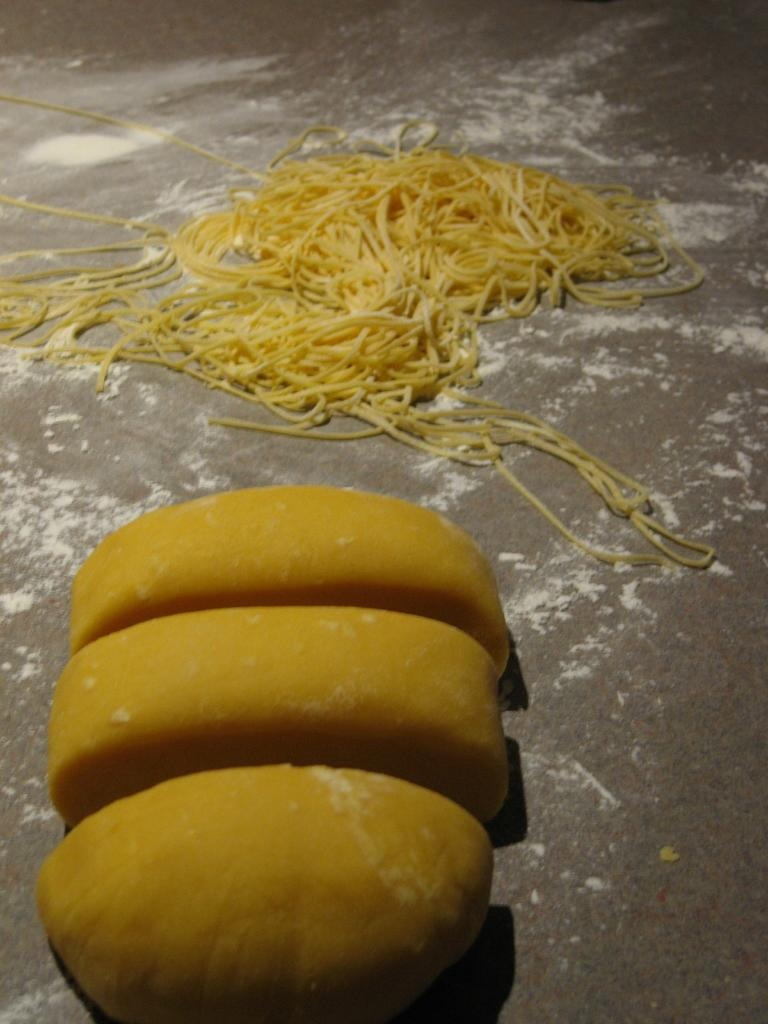What color are the objects in the image? The objects in the image are yellow. What can be observed about the placement of the objects in the image? The objects are placed on a surface in the image. How many frogs are sitting on the dress in the image? There are no frogs or dresses present in the image. 